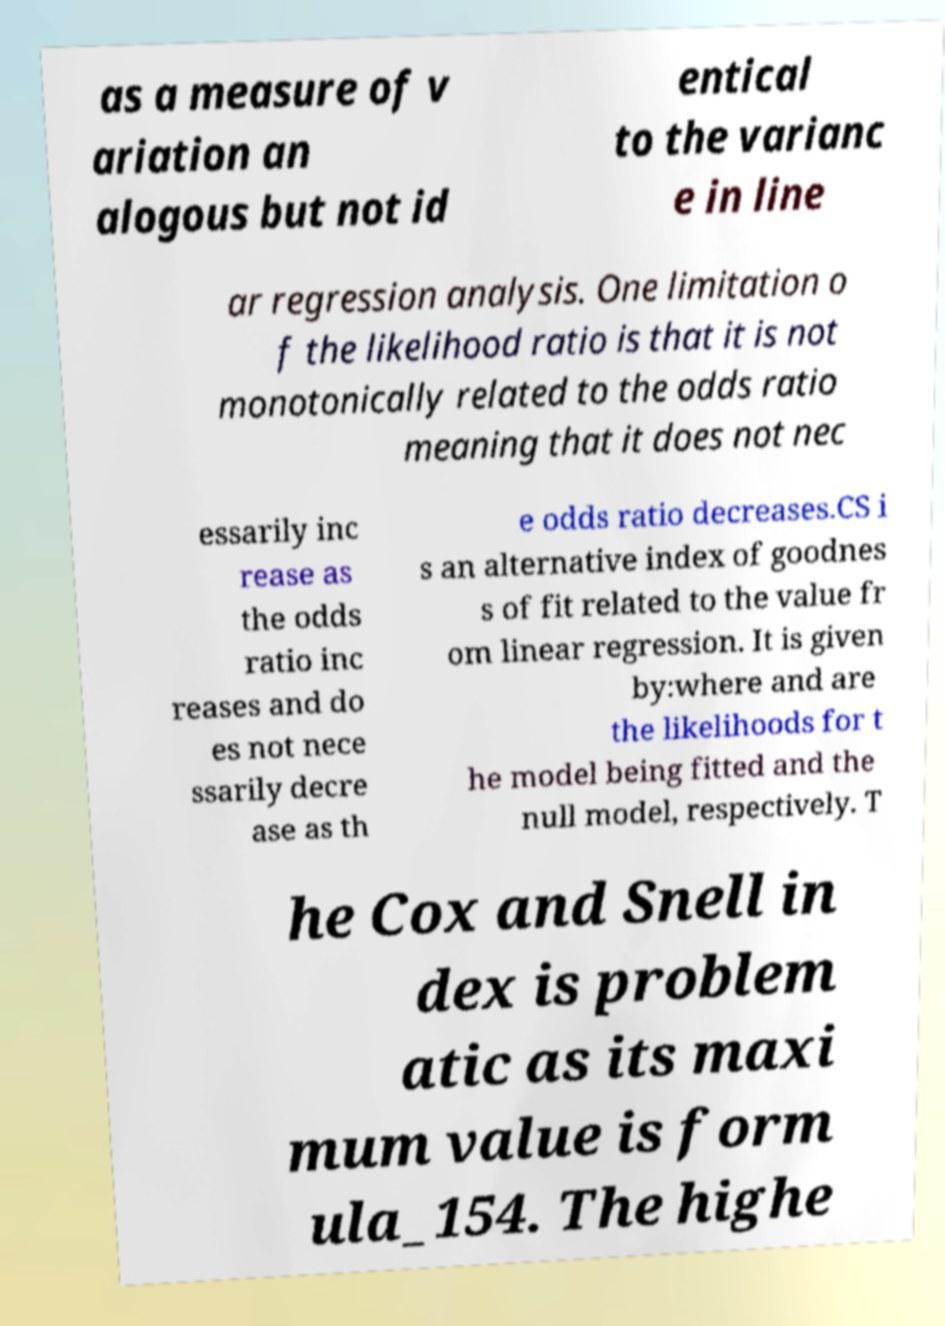There's text embedded in this image that I need extracted. Can you transcribe it verbatim? as a measure of v ariation an alogous but not id entical to the varianc e in line ar regression analysis. One limitation o f the likelihood ratio is that it is not monotonically related to the odds ratio meaning that it does not nec essarily inc rease as the odds ratio inc reases and do es not nece ssarily decre ase as th e odds ratio decreases.CS i s an alternative index of goodnes s of fit related to the value fr om linear regression. It is given by:where and are the likelihoods for t he model being fitted and the null model, respectively. T he Cox and Snell in dex is problem atic as its maxi mum value is form ula_154. The highe 